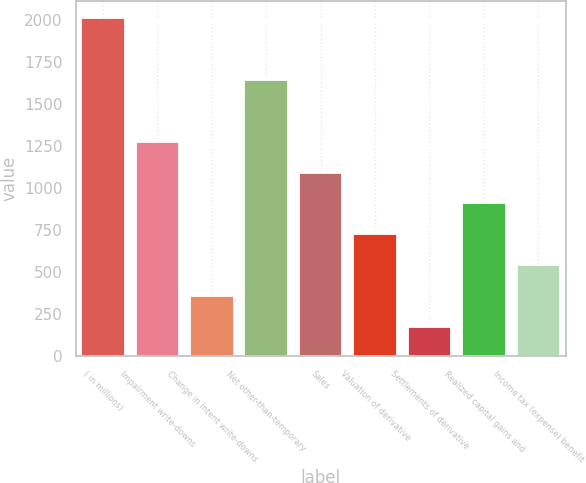Convert chart. <chart><loc_0><loc_0><loc_500><loc_500><bar_chart><fcel>( in millions)<fcel>Impairment write-downs<fcel>Change in intent write-downs<fcel>Net other-than-temporary<fcel>Sales<fcel>Valuation of derivative<fcel>Settlements of derivative<fcel>Realized capital gains and<fcel>Income tax (expense) benefit<nl><fcel>2010<fcel>1275.6<fcel>357.6<fcel>1642.8<fcel>1092<fcel>724.8<fcel>174<fcel>908.4<fcel>541.2<nl></chart> 